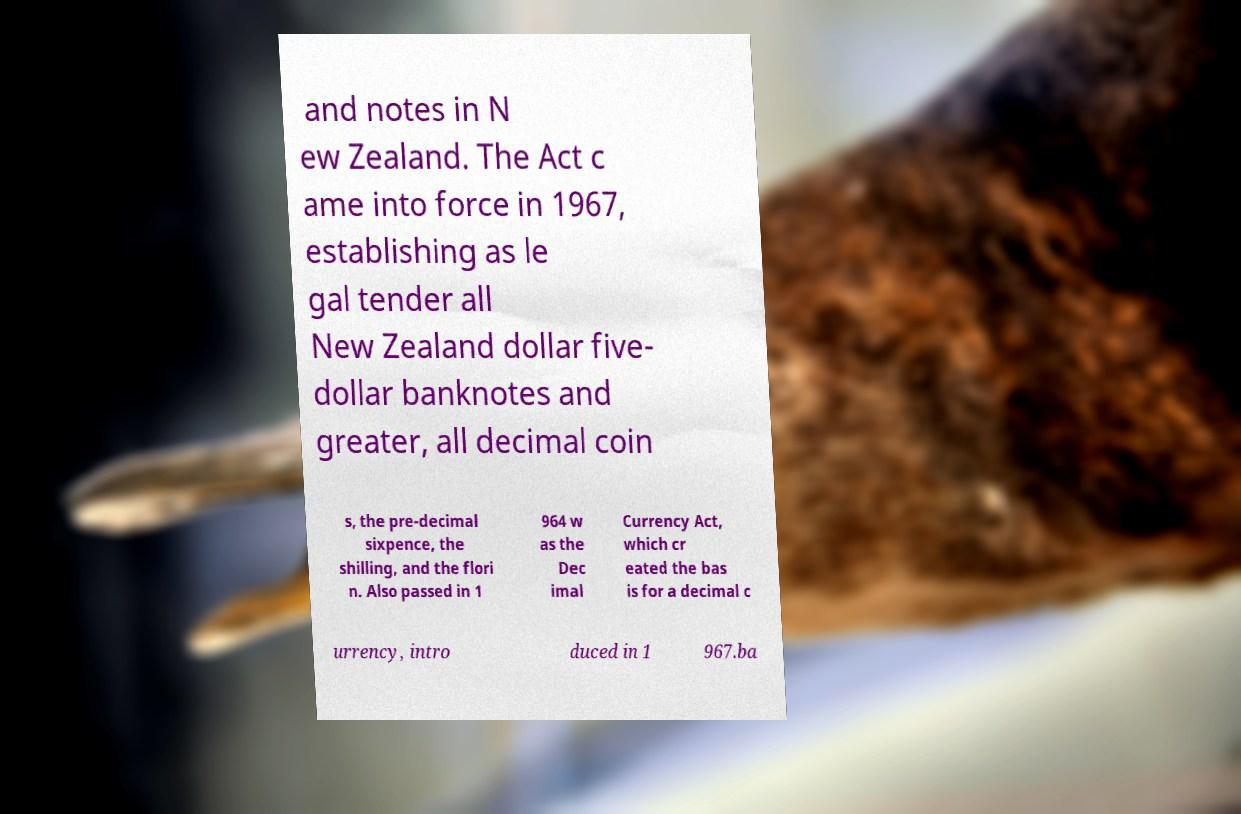Please read and relay the text visible in this image. What does it say? and notes in N ew Zealand. The Act c ame into force in 1967, establishing as le gal tender all New Zealand dollar five- dollar banknotes and greater, all decimal coin s, the pre-decimal sixpence, the shilling, and the flori n. Also passed in 1 964 w as the Dec imal Currency Act, which cr eated the bas is for a decimal c urrency, intro duced in 1 967.ba 